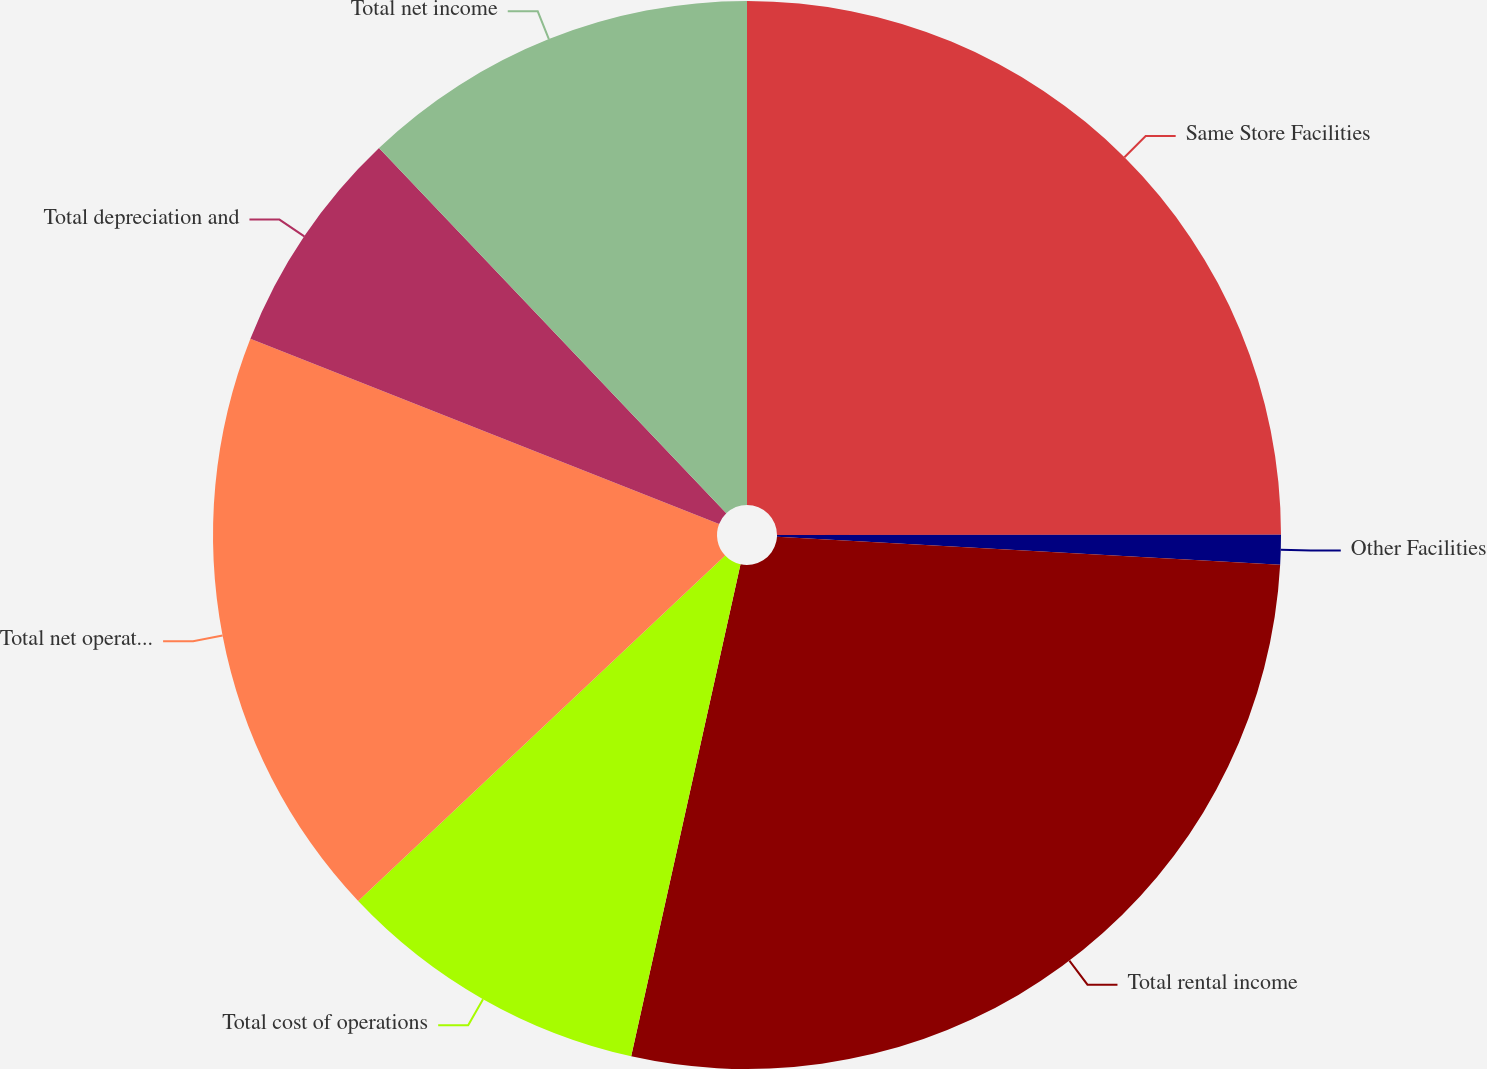<chart> <loc_0><loc_0><loc_500><loc_500><pie_chart><fcel>Same Store Facilities<fcel>Other Facilities<fcel>Total rental income<fcel>Total cost of operations<fcel>Total net operating income<fcel>Total depreciation and<fcel>Total net income<nl><fcel>24.99%<fcel>0.9%<fcel>27.59%<fcel>9.5%<fcel>18.01%<fcel>6.91%<fcel>12.1%<nl></chart> 